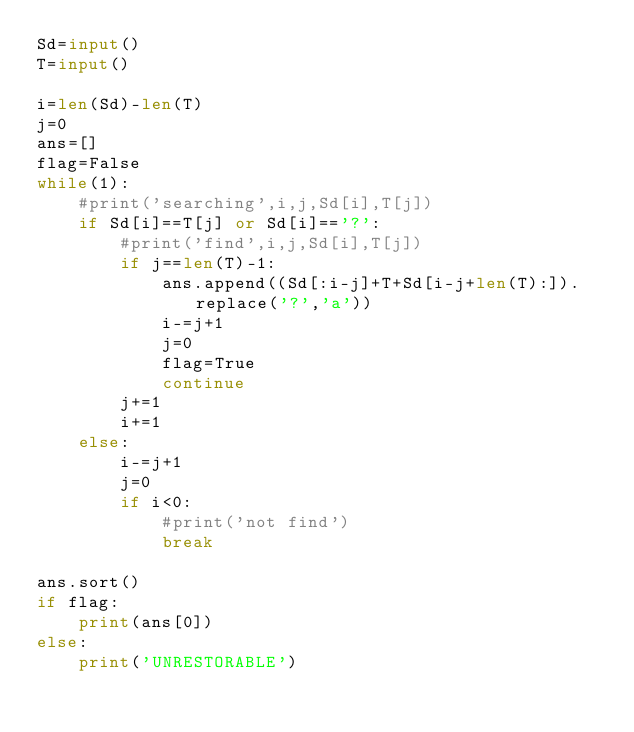Convert code to text. <code><loc_0><loc_0><loc_500><loc_500><_Python_>Sd=input()
T=input()
 
i=len(Sd)-len(T)
j=0
ans=[]
flag=False
while(1):
    #print('searching',i,j,Sd[i],T[j])
    if Sd[i]==T[j] or Sd[i]=='?':
        #print('find',i,j,Sd[i],T[j])
        if j==len(T)-1:
            ans.append((Sd[:i-j]+T+Sd[i-j+len(T):]).replace('?','a'))
            i-=j+1
            j=0
            flag=True
            continue
        j+=1
        i+=1
    else:
        i-=j+1
        j=0
        if i<0:
            #print('not find')
            break

ans.sort()
if flag:
    print(ans[0])
else:
    print('UNRESTORABLE')</code> 